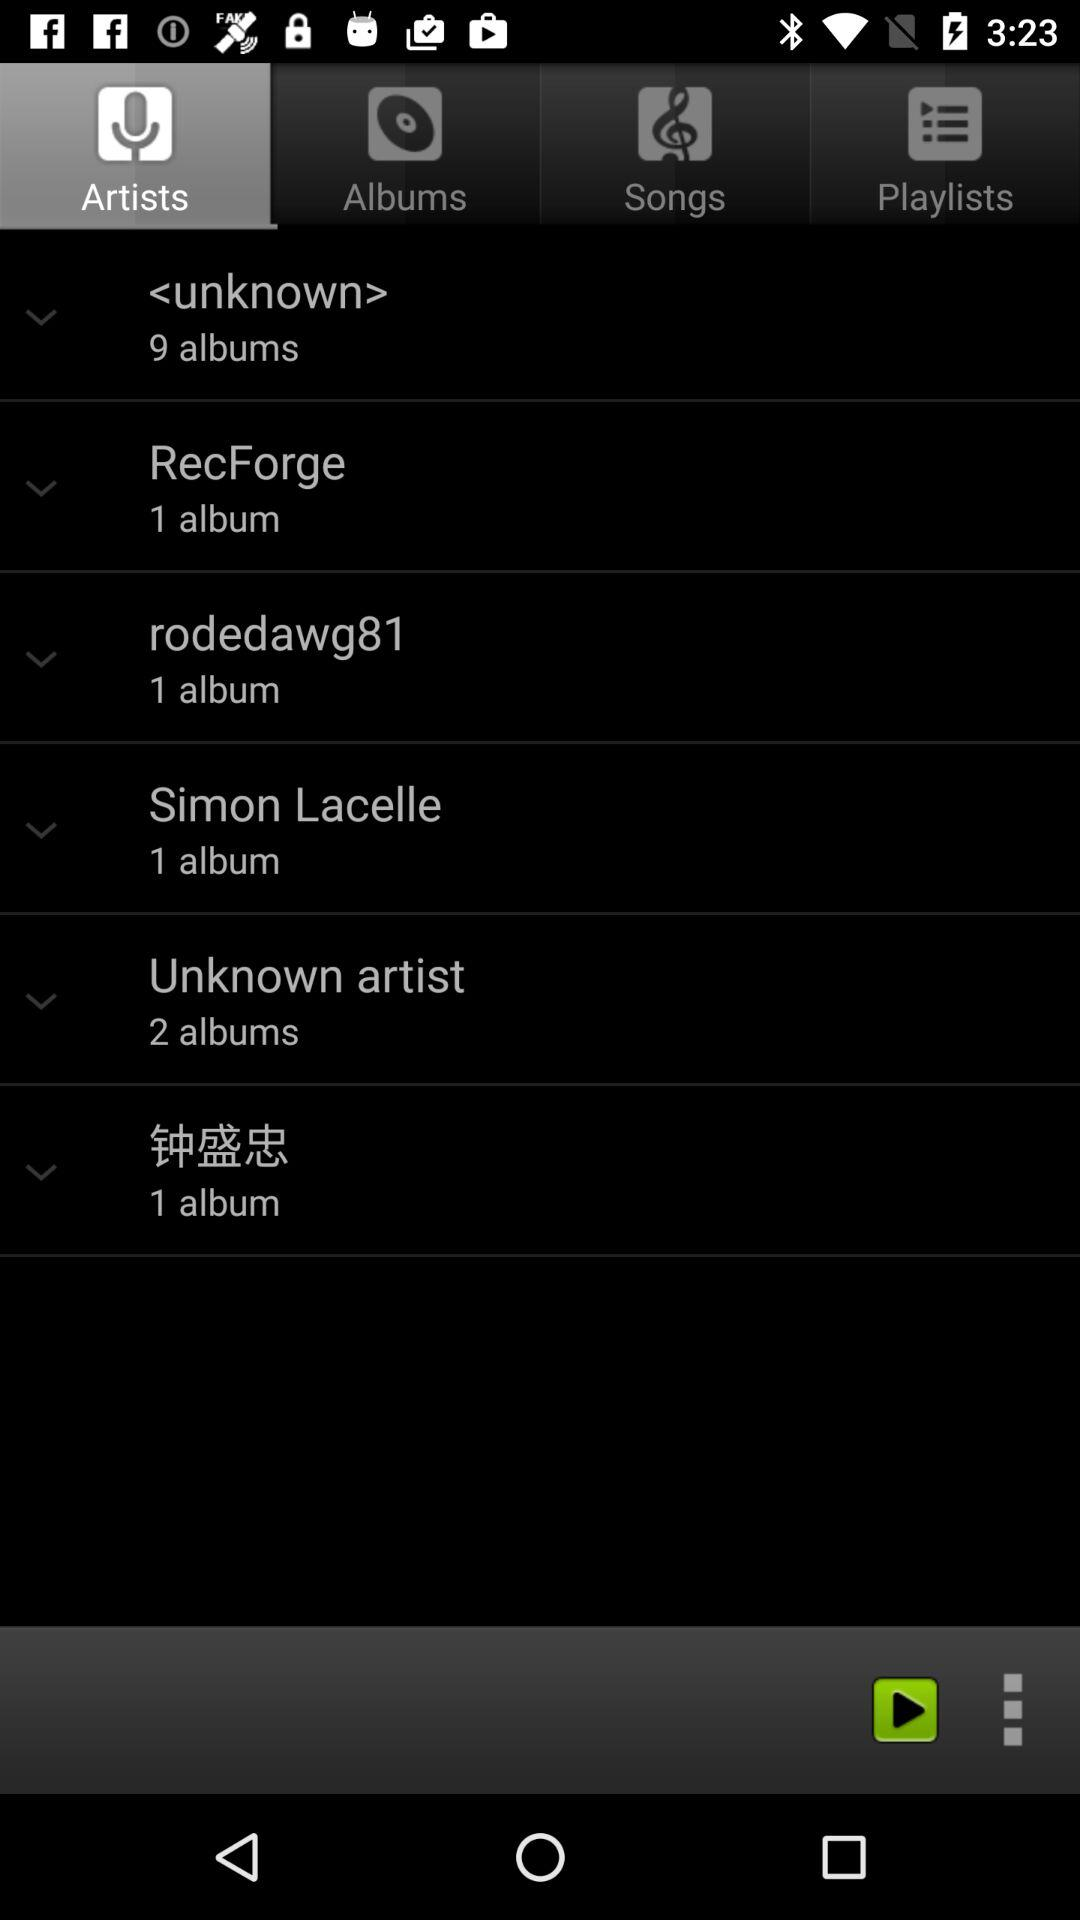Which tab has been selected? The selected tab is "Artists". 